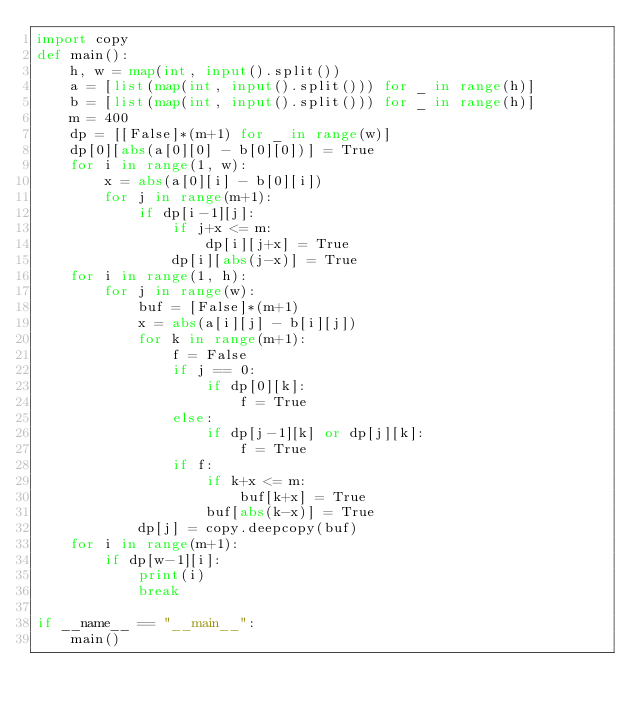<code> <loc_0><loc_0><loc_500><loc_500><_Python_>import copy
def main():
    h, w = map(int, input().split())
    a = [list(map(int, input().split())) for _ in range(h)]
    b = [list(map(int, input().split())) for _ in range(h)]
    m = 400
    dp = [[False]*(m+1) for _ in range(w)]
    dp[0][abs(a[0][0] - b[0][0])] = True
    for i in range(1, w):
        x = abs(a[0][i] - b[0][i])
        for j in range(m+1):
            if dp[i-1][j]:
                if j+x <= m:
                    dp[i][j+x] = True
                dp[i][abs(j-x)] = True
    for i in range(1, h):
        for j in range(w):
            buf = [False]*(m+1)
            x = abs(a[i][j] - b[i][j])
            for k in range(m+1):
                f = False
                if j == 0:
                    if dp[0][k]:
                        f = True
                else:
                    if dp[j-1][k] or dp[j][k]:
                        f = True
                if f:
                    if k+x <= m:
                        buf[k+x] = True
                    buf[abs(k-x)] = True
            dp[j] = copy.deepcopy(buf)
    for i in range(m+1):
        if dp[w-1][i]:
            print(i)
            break

if __name__ == "__main__":
    main()
</code> 